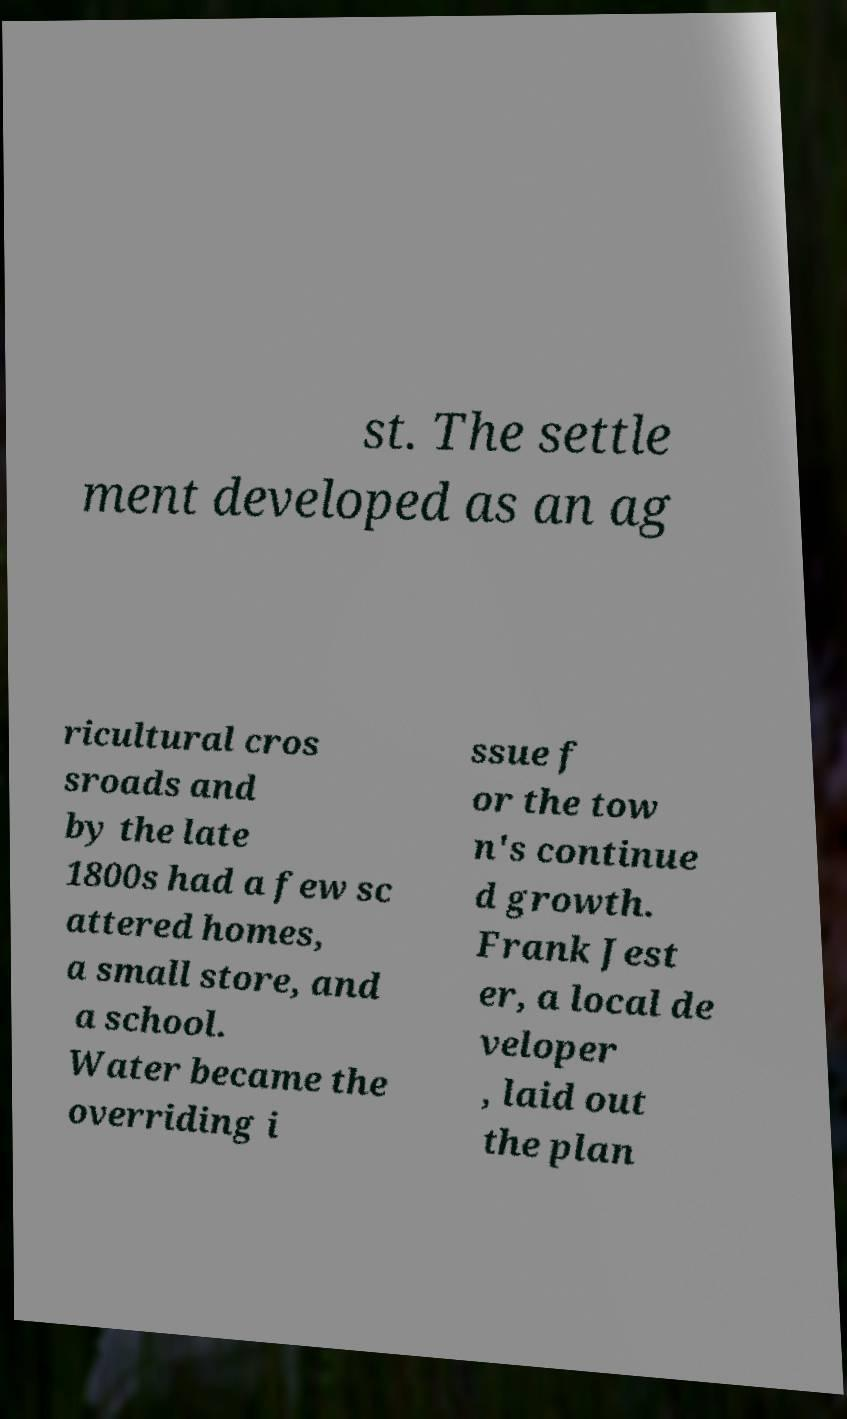What messages or text are displayed in this image? I need them in a readable, typed format. st. The settle ment developed as an ag ricultural cros sroads and by the late 1800s had a few sc attered homes, a small store, and a school. Water became the overriding i ssue f or the tow n's continue d growth. Frank Jest er, a local de veloper , laid out the plan 